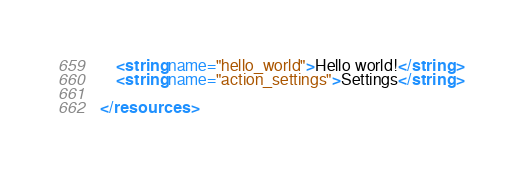<code> <loc_0><loc_0><loc_500><loc_500><_XML_>    <string name="hello_world">Hello world!</string>
    <string name="action_settings">Settings</string>

</resources>
</code> 